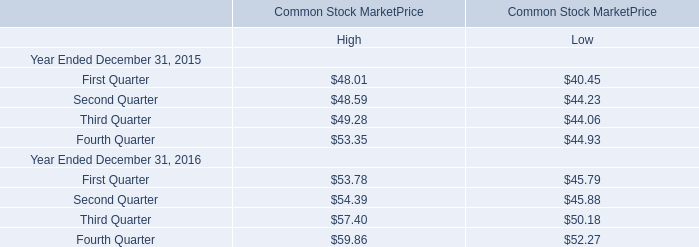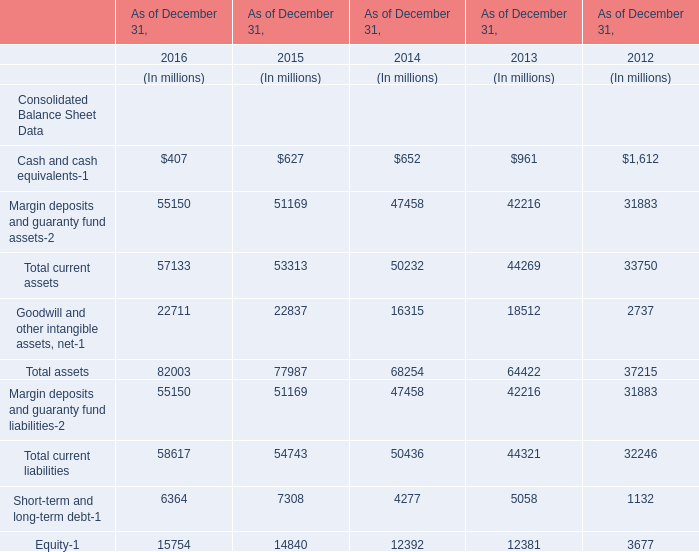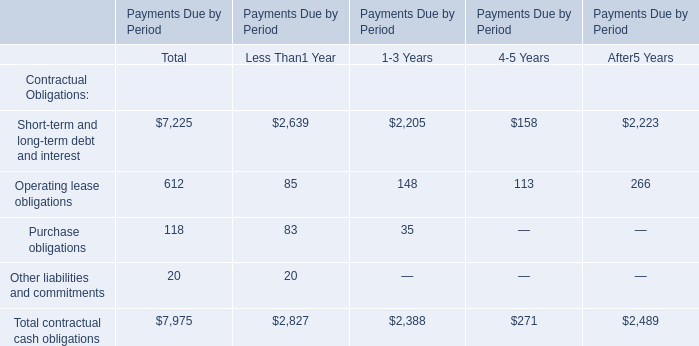In the year with the most Total assets, what is the growth rate of Total current liabilities? 
Computations: ((58617 - 54743) / 54743)
Answer: 0.07077. 